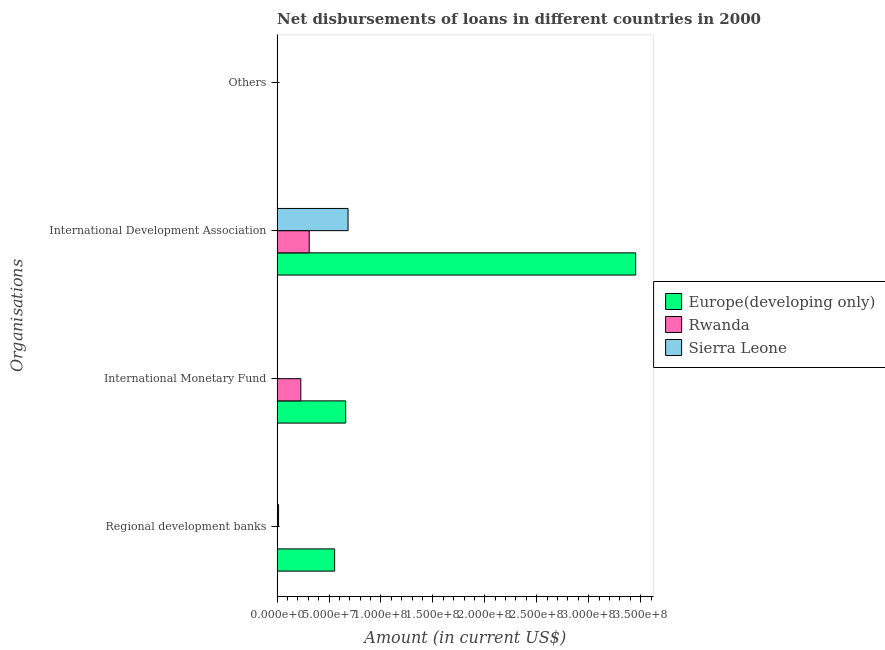Are the number of bars per tick equal to the number of legend labels?
Your answer should be very brief. No. How many bars are there on the 2nd tick from the top?
Provide a succinct answer. 3. How many bars are there on the 3rd tick from the bottom?
Offer a terse response. 3. What is the label of the 3rd group of bars from the top?
Make the answer very short. International Monetary Fund. What is the amount of loan disimbursed by regional development banks in Europe(developing only)?
Provide a short and direct response. 5.54e+07. Across all countries, what is the maximum amount of loan disimbursed by international development association?
Your response must be concise. 3.45e+08. In which country was the amount of loan disimbursed by regional development banks maximum?
Offer a very short reply. Europe(developing only). What is the total amount of loan disimbursed by international monetary fund in the graph?
Make the answer very short. 8.88e+07. What is the difference between the amount of loan disimbursed by international development association in Rwanda and that in Europe(developing only)?
Your response must be concise. -3.14e+08. What is the difference between the amount of loan disimbursed by regional development banks in Europe(developing only) and the amount of loan disimbursed by international monetary fund in Sierra Leone?
Give a very brief answer. 5.54e+07. What is the average amount of loan disimbursed by regional development banks per country?
Keep it short and to the point. 1.89e+07. What is the difference between the amount of loan disimbursed by regional development banks and amount of loan disimbursed by international development association in Sierra Leone?
Your response must be concise. -6.69e+07. In how many countries, is the amount of loan disimbursed by international monetary fund greater than 270000000 US$?
Offer a terse response. 0. What is the ratio of the amount of loan disimbursed by international development association in Europe(developing only) to that in Rwanda?
Offer a very short reply. 11.17. What is the difference between the highest and the second highest amount of loan disimbursed by international development association?
Keep it short and to the point. 2.77e+08. What is the difference between the highest and the lowest amount of loan disimbursed by international monetary fund?
Give a very brief answer. 6.60e+07. Is it the case that in every country, the sum of the amount of loan disimbursed by regional development banks and amount of loan disimbursed by international monetary fund is greater than the amount of loan disimbursed by international development association?
Give a very brief answer. No. How many bars are there?
Give a very brief answer. 7. Are all the bars in the graph horizontal?
Your answer should be compact. Yes. What is the difference between two consecutive major ticks on the X-axis?
Your answer should be compact. 5.00e+07. Are the values on the major ticks of X-axis written in scientific E-notation?
Offer a terse response. Yes. Does the graph contain any zero values?
Offer a very short reply. Yes. Does the graph contain grids?
Your response must be concise. No. Where does the legend appear in the graph?
Provide a succinct answer. Center right. How are the legend labels stacked?
Your answer should be very brief. Vertical. What is the title of the graph?
Your response must be concise. Net disbursements of loans in different countries in 2000. Does "Macedonia" appear as one of the legend labels in the graph?
Your response must be concise. No. What is the label or title of the X-axis?
Offer a terse response. Amount (in current US$). What is the label or title of the Y-axis?
Provide a short and direct response. Organisations. What is the Amount (in current US$) of Europe(developing only) in Regional development banks?
Your response must be concise. 5.54e+07. What is the Amount (in current US$) of Sierra Leone in Regional development banks?
Your answer should be compact. 1.39e+06. What is the Amount (in current US$) in Europe(developing only) in International Monetary Fund?
Give a very brief answer. 6.60e+07. What is the Amount (in current US$) of Rwanda in International Monetary Fund?
Provide a succinct answer. 2.28e+07. What is the Amount (in current US$) of Europe(developing only) in International Development Association?
Keep it short and to the point. 3.45e+08. What is the Amount (in current US$) in Rwanda in International Development Association?
Provide a succinct answer. 3.09e+07. What is the Amount (in current US$) of Sierra Leone in International Development Association?
Ensure brevity in your answer.  6.83e+07. What is the Amount (in current US$) of Europe(developing only) in Others?
Your response must be concise. 0. What is the Amount (in current US$) of Rwanda in Others?
Your answer should be very brief. 0. What is the Amount (in current US$) in Sierra Leone in Others?
Your answer should be very brief. 0. Across all Organisations, what is the maximum Amount (in current US$) in Europe(developing only)?
Your answer should be compact. 3.45e+08. Across all Organisations, what is the maximum Amount (in current US$) of Rwanda?
Provide a short and direct response. 3.09e+07. Across all Organisations, what is the maximum Amount (in current US$) in Sierra Leone?
Offer a very short reply. 6.83e+07. Across all Organisations, what is the minimum Amount (in current US$) of Europe(developing only)?
Ensure brevity in your answer.  0. Across all Organisations, what is the minimum Amount (in current US$) in Rwanda?
Ensure brevity in your answer.  0. What is the total Amount (in current US$) of Europe(developing only) in the graph?
Your response must be concise. 4.67e+08. What is the total Amount (in current US$) in Rwanda in the graph?
Give a very brief answer. 5.37e+07. What is the total Amount (in current US$) in Sierra Leone in the graph?
Your answer should be compact. 6.97e+07. What is the difference between the Amount (in current US$) of Europe(developing only) in Regional development banks and that in International Monetary Fund?
Provide a short and direct response. -1.06e+07. What is the difference between the Amount (in current US$) of Europe(developing only) in Regional development banks and that in International Development Association?
Offer a terse response. -2.90e+08. What is the difference between the Amount (in current US$) in Sierra Leone in Regional development banks and that in International Development Association?
Keep it short and to the point. -6.69e+07. What is the difference between the Amount (in current US$) of Europe(developing only) in International Monetary Fund and that in International Development Association?
Your response must be concise. -2.79e+08. What is the difference between the Amount (in current US$) of Rwanda in International Monetary Fund and that in International Development Association?
Your answer should be very brief. -8.09e+06. What is the difference between the Amount (in current US$) in Europe(developing only) in Regional development banks and the Amount (in current US$) in Rwanda in International Monetary Fund?
Make the answer very short. 3.26e+07. What is the difference between the Amount (in current US$) in Europe(developing only) in Regional development banks and the Amount (in current US$) in Rwanda in International Development Association?
Provide a succinct answer. 2.45e+07. What is the difference between the Amount (in current US$) of Europe(developing only) in Regional development banks and the Amount (in current US$) of Sierra Leone in International Development Association?
Offer a terse response. -1.29e+07. What is the difference between the Amount (in current US$) of Europe(developing only) in International Monetary Fund and the Amount (in current US$) of Rwanda in International Development Association?
Your answer should be very brief. 3.51e+07. What is the difference between the Amount (in current US$) in Europe(developing only) in International Monetary Fund and the Amount (in current US$) in Sierra Leone in International Development Association?
Offer a terse response. -2.27e+06. What is the difference between the Amount (in current US$) of Rwanda in International Monetary Fund and the Amount (in current US$) of Sierra Leone in International Development Association?
Offer a terse response. -4.55e+07. What is the average Amount (in current US$) of Europe(developing only) per Organisations?
Keep it short and to the point. 1.17e+08. What is the average Amount (in current US$) in Rwanda per Organisations?
Provide a short and direct response. 1.34e+07. What is the average Amount (in current US$) in Sierra Leone per Organisations?
Provide a succinct answer. 1.74e+07. What is the difference between the Amount (in current US$) of Europe(developing only) and Amount (in current US$) of Sierra Leone in Regional development banks?
Ensure brevity in your answer.  5.40e+07. What is the difference between the Amount (in current US$) in Europe(developing only) and Amount (in current US$) in Rwanda in International Monetary Fund?
Provide a short and direct response. 4.32e+07. What is the difference between the Amount (in current US$) in Europe(developing only) and Amount (in current US$) in Rwanda in International Development Association?
Make the answer very short. 3.14e+08. What is the difference between the Amount (in current US$) of Europe(developing only) and Amount (in current US$) of Sierra Leone in International Development Association?
Provide a succinct answer. 2.77e+08. What is the difference between the Amount (in current US$) in Rwanda and Amount (in current US$) in Sierra Leone in International Development Association?
Offer a very short reply. -3.74e+07. What is the ratio of the Amount (in current US$) in Europe(developing only) in Regional development banks to that in International Monetary Fund?
Your response must be concise. 0.84. What is the ratio of the Amount (in current US$) of Europe(developing only) in Regional development banks to that in International Development Association?
Keep it short and to the point. 0.16. What is the ratio of the Amount (in current US$) of Sierra Leone in Regional development banks to that in International Development Association?
Give a very brief answer. 0.02. What is the ratio of the Amount (in current US$) in Europe(developing only) in International Monetary Fund to that in International Development Association?
Provide a short and direct response. 0.19. What is the ratio of the Amount (in current US$) of Rwanda in International Monetary Fund to that in International Development Association?
Offer a terse response. 0.74. What is the difference between the highest and the second highest Amount (in current US$) in Europe(developing only)?
Your answer should be very brief. 2.79e+08. What is the difference between the highest and the lowest Amount (in current US$) of Europe(developing only)?
Make the answer very short. 3.45e+08. What is the difference between the highest and the lowest Amount (in current US$) of Rwanda?
Offer a terse response. 3.09e+07. What is the difference between the highest and the lowest Amount (in current US$) of Sierra Leone?
Keep it short and to the point. 6.83e+07. 